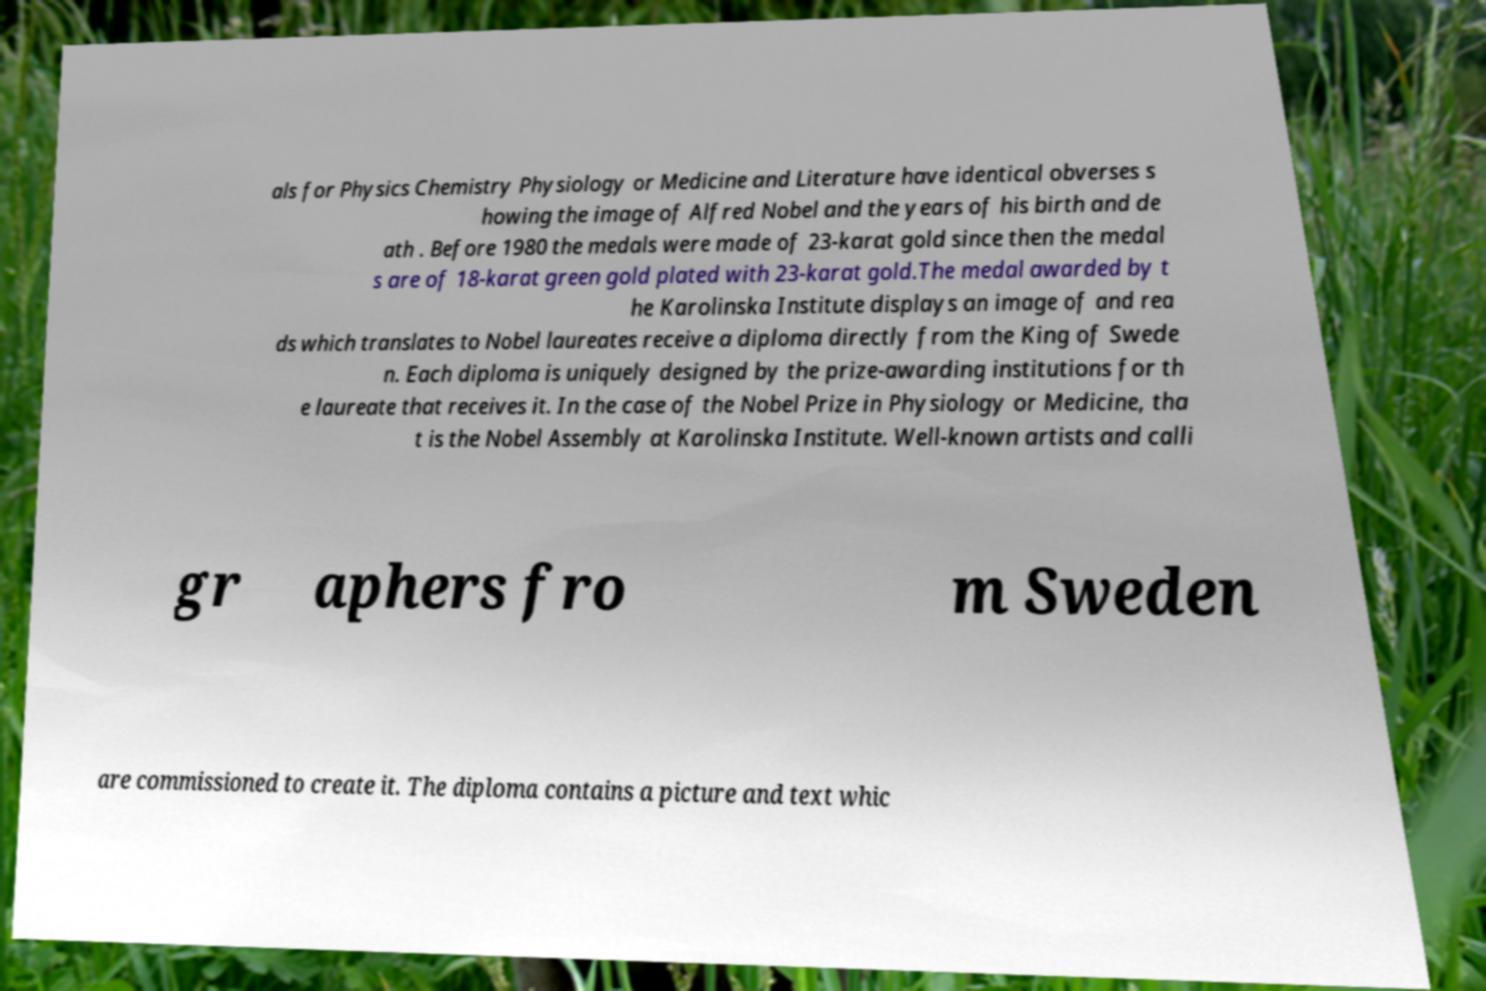What messages or text are displayed in this image? I need them in a readable, typed format. als for Physics Chemistry Physiology or Medicine and Literature have identical obverses s howing the image of Alfred Nobel and the years of his birth and de ath . Before 1980 the medals were made of 23-karat gold since then the medal s are of 18-karat green gold plated with 23-karat gold.The medal awarded by t he Karolinska Institute displays an image of and rea ds which translates to Nobel laureates receive a diploma directly from the King of Swede n. Each diploma is uniquely designed by the prize-awarding institutions for th e laureate that receives it. In the case of the Nobel Prize in Physiology or Medicine, tha t is the Nobel Assembly at Karolinska Institute. Well-known artists and calli gr aphers fro m Sweden are commissioned to create it. The diploma contains a picture and text whic 